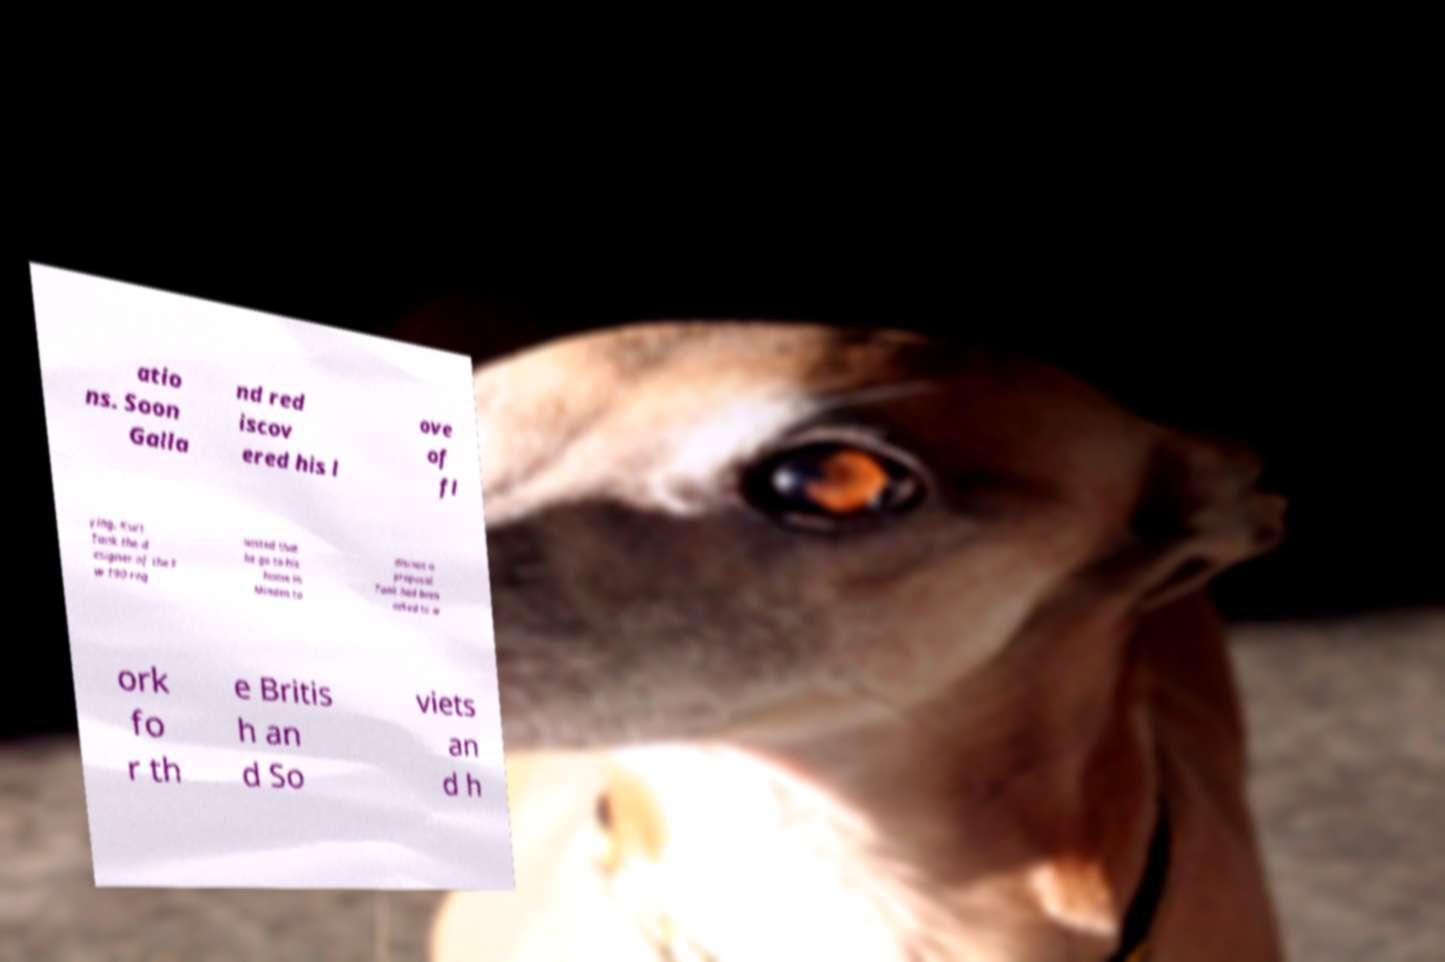Could you extract and type out the text from this image? atio ns. Soon Galla nd red iscov ered his l ove of fl ying. Kurt Tank the d esigner of the F w 190 req uested that he go to his home in Minden to discuss a proposal. Tank had been asked to w ork fo r th e Britis h an d So viets an d h 